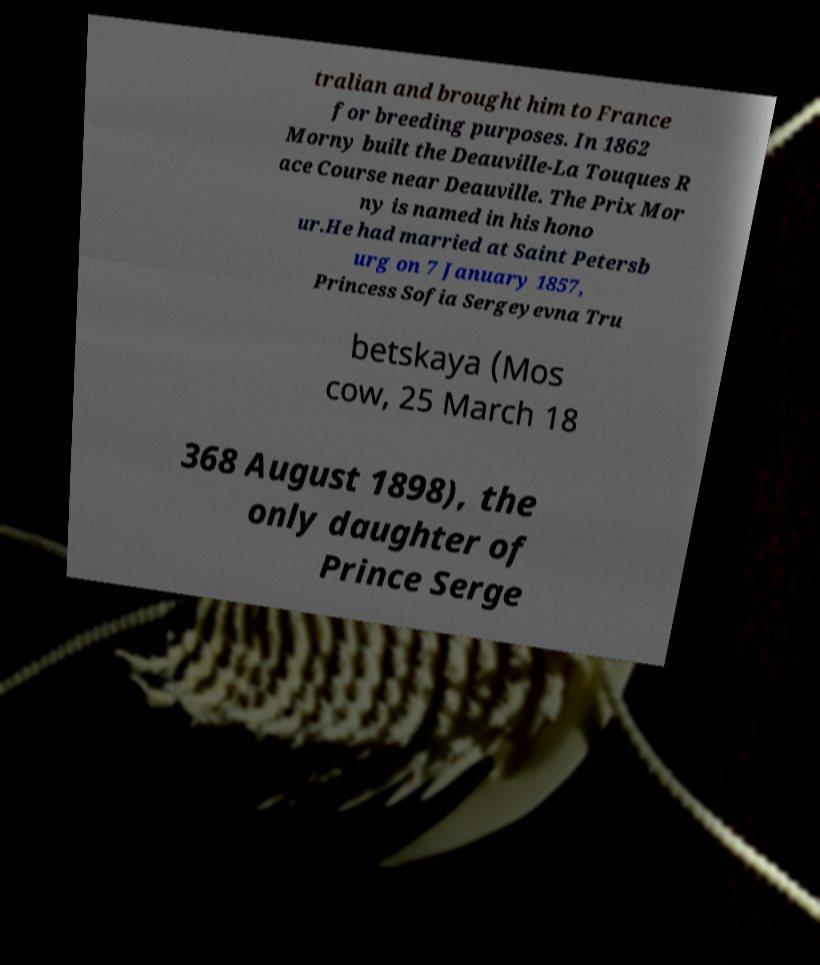What messages or text are displayed in this image? I need them in a readable, typed format. tralian and brought him to France for breeding purposes. In 1862 Morny built the Deauville-La Touques R ace Course near Deauville. The Prix Mor ny is named in his hono ur.He had married at Saint Petersb urg on 7 January 1857, Princess Sofia Sergeyevna Tru betskaya (Mos cow, 25 March 18 368 August 1898), the only daughter of Prince Serge 